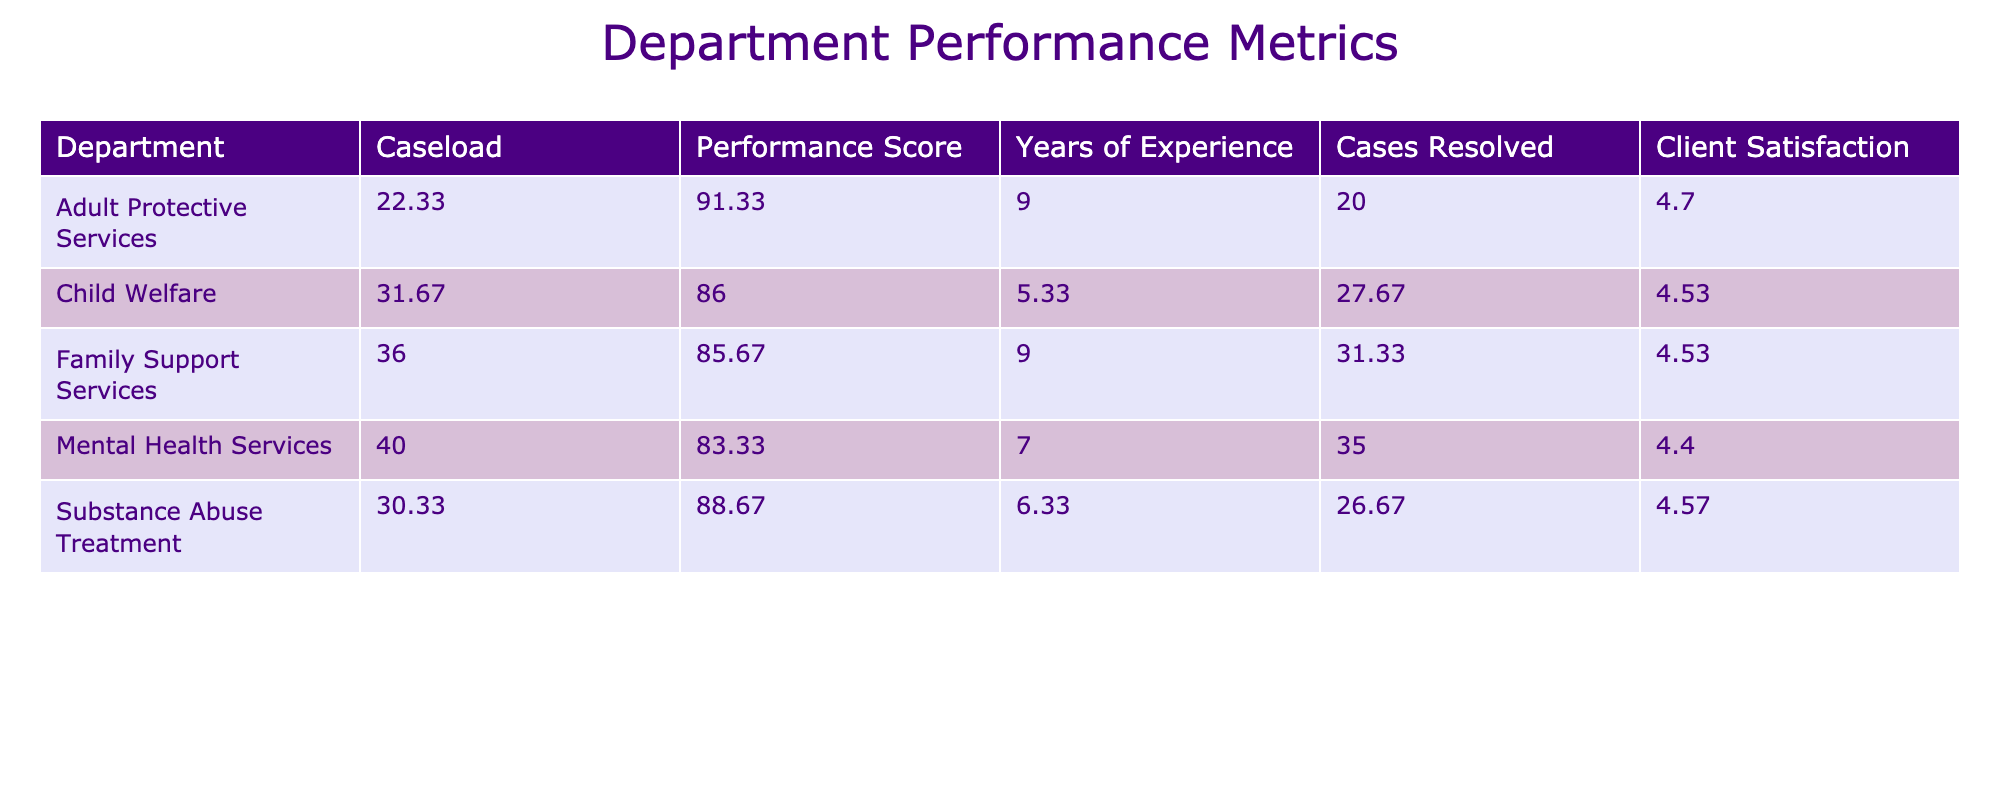What is the average caseload for the Adult Protective Services department? The Adult Protective Services department has three entries: 22, 25, and 20. To find the average, add these values: 22 + 25 + 20 = 67. Then divide by the number of entries, which is 3: 67 / 3 = 22.33.
Answer: 22.33 Which department has the highest average performance score? By evaluating the average performance scores from each department, we find: Child Welfare (86), Adult Protective Services (91.33), Mental Health Services (83.33), Substance Abuse Treatment (88.67), and Family Support Services (85.67). Adult Protective Services has the highest average score at 91.33.
Answer: Adult Protective Services Is the average client satisfaction score for Substance Abuse Treatment above 4.5? The Substance Abuse Treatment department has three entries with satisfaction scores of 4.6, 4.3, and 4.8. Calculate the average: (4.6 + 4.3 + 4.8) / 3 = 4.5667, which is above 4.5.
Answer: Yes What is the difference in years of experience between the department with the most cases resolved and the one with the least? The department with the most cases resolved is Mental Health Services, with an average of 35 cases resolved (from entries 35, 33, and 37). The department with the least is Adult Protective Services, with an average of 20 cases resolved (from entries 20, 22, and 18). The difference in years of experience is average years of experience of Mental Health Services (7) - Adult Protective Services (9) = 7 - 9 = -2.
Answer: -2 What is the total number of cases resolved across all departments? To calculate the total number of cases resolved, sum the average resolved cases from each department: 28 + 22 + 30 + 26 + 31 + 30 + 33 = 200.
Answer: 200 